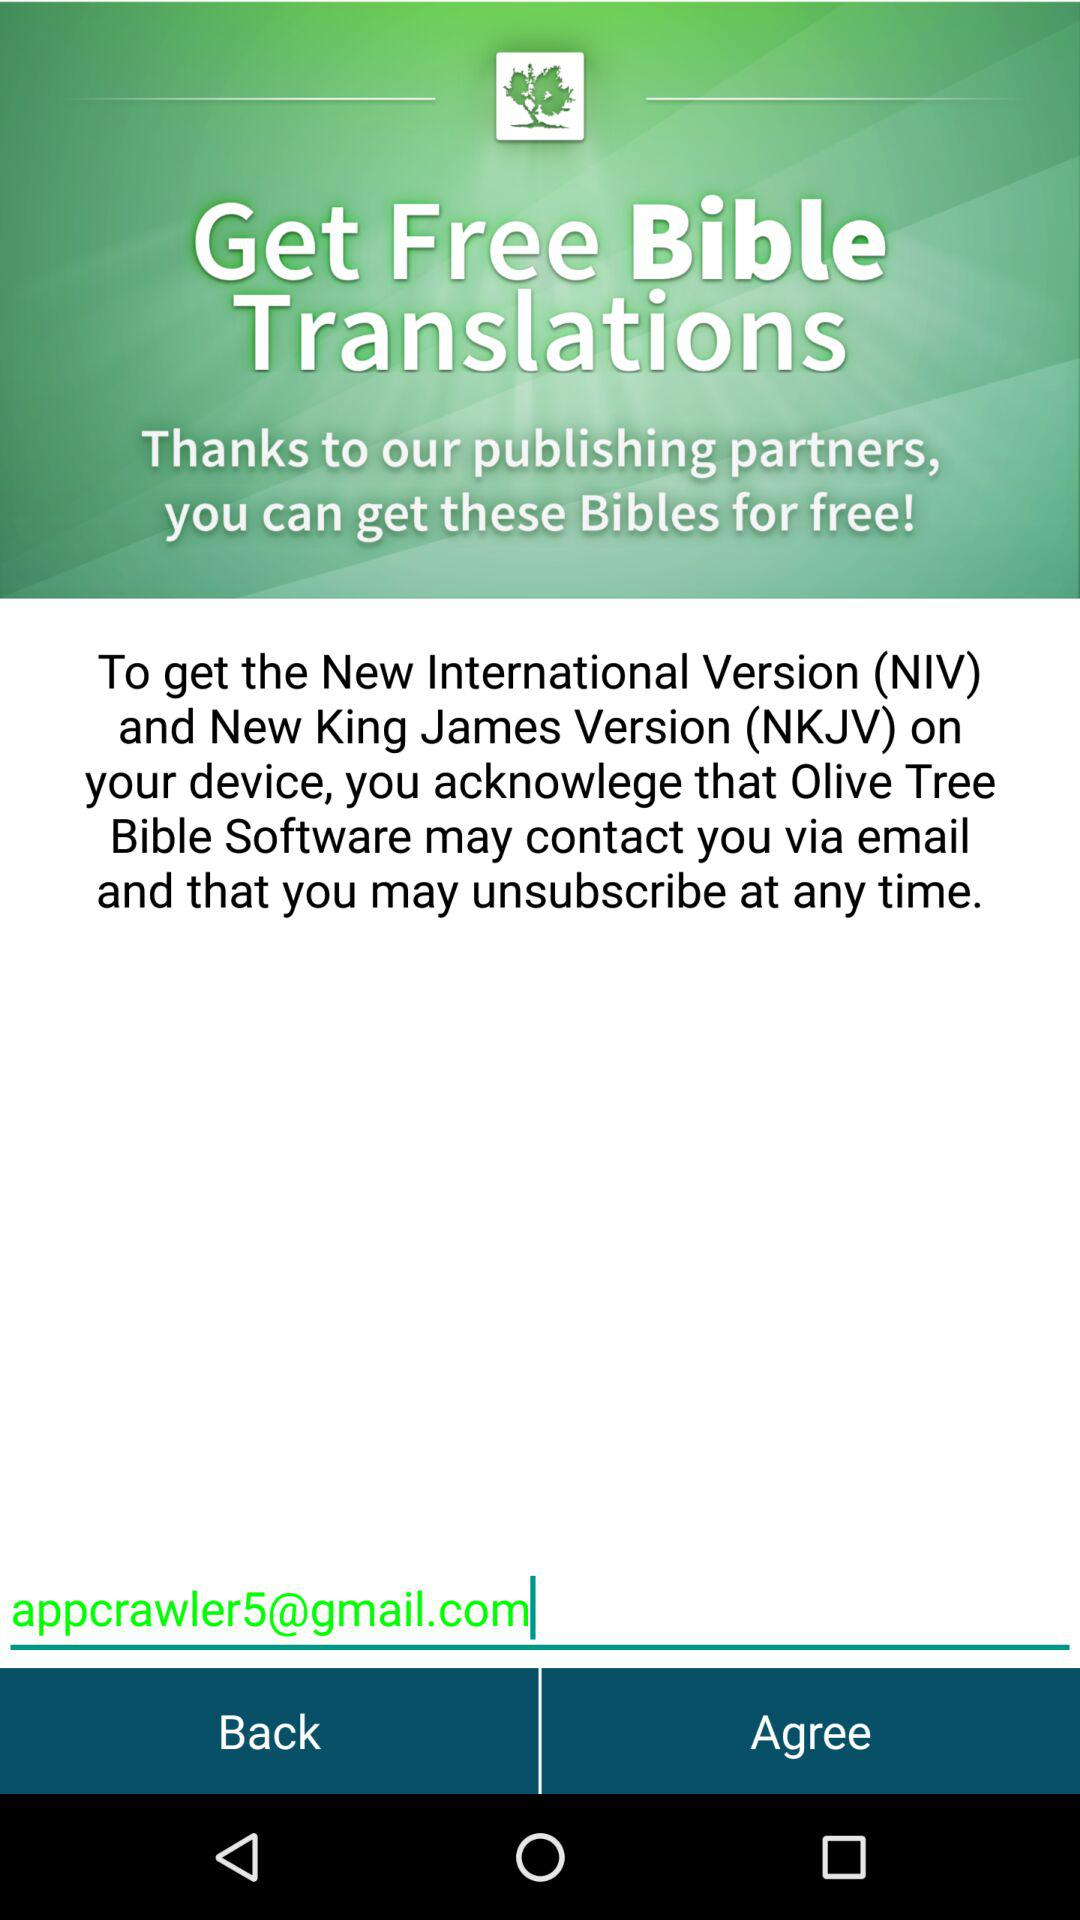What is the app name?
When the provided information is insufficient, respond with <no answer>. <no answer> 